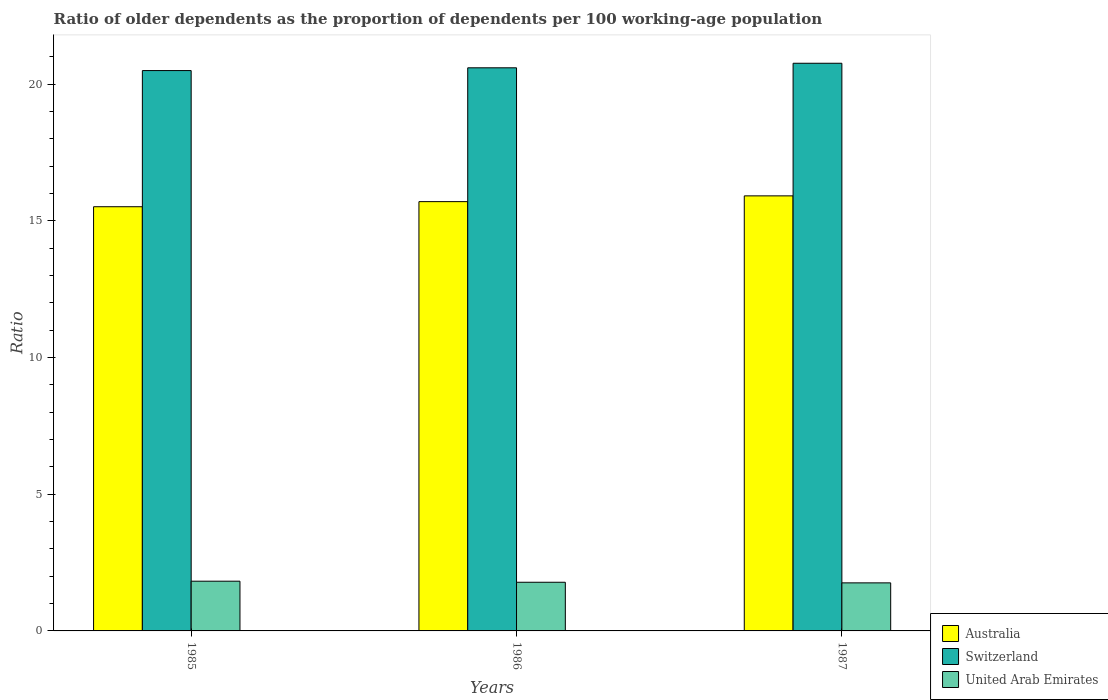How many different coloured bars are there?
Your answer should be very brief. 3. Are the number of bars on each tick of the X-axis equal?
Make the answer very short. Yes. How many bars are there on the 1st tick from the left?
Give a very brief answer. 3. What is the age dependency ratio(old) in Australia in 1985?
Your answer should be very brief. 15.51. Across all years, what is the maximum age dependency ratio(old) in Australia?
Offer a very short reply. 15.91. Across all years, what is the minimum age dependency ratio(old) in Australia?
Your response must be concise. 15.51. In which year was the age dependency ratio(old) in Australia maximum?
Your response must be concise. 1987. What is the total age dependency ratio(old) in Australia in the graph?
Your answer should be compact. 47.12. What is the difference between the age dependency ratio(old) in United Arab Emirates in 1985 and that in 1986?
Your answer should be compact. 0.04. What is the difference between the age dependency ratio(old) in Australia in 1986 and the age dependency ratio(old) in Switzerland in 1987?
Your answer should be very brief. -5.06. What is the average age dependency ratio(old) in Australia per year?
Give a very brief answer. 15.71. In the year 1987, what is the difference between the age dependency ratio(old) in Australia and age dependency ratio(old) in Switzerland?
Provide a succinct answer. -4.85. What is the ratio of the age dependency ratio(old) in Australia in 1985 to that in 1986?
Provide a succinct answer. 0.99. What is the difference between the highest and the second highest age dependency ratio(old) in Australia?
Keep it short and to the point. 0.21. What is the difference between the highest and the lowest age dependency ratio(old) in Switzerland?
Provide a succinct answer. 0.27. What does the 3rd bar from the right in 1985 represents?
Give a very brief answer. Australia. How many bars are there?
Offer a very short reply. 9. Are all the bars in the graph horizontal?
Give a very brief answer. No. How many years are there in the graph?
Make the answer very short. 3. What is the difference between two consecutive major ticks on the Y-axis?
Provide a succinct answer. 5. Are the values on the major ticks of Y-axis written in scientific E-notation?
Offer a very short reply. No. What is the title of the graph?
Your answer should be very brief. Ratio of older dependents as the proportion of dependents per 100 working-age population. What is the label or title of the X-axis?
Keep it short and to the point. Years. What is the label or title of the Y-axis?
Provide a succinct answer. Ratio. What is the Ratio in Australia in 1985?
Provide a succinct answer. 15.51. What is the Ratio in Switzerland in 1985?
Provide a succinct answer. 20.49. What is the Ratio of United Arab Emirates in 1985?
Your answer should be very brief. 1.82. What is the Ratio in Australia in 1986?
Give a very brief answer. 15.7. What is the Ratio of Switzerland in 1986?
Give a very brief answer. 20.59. What is the Ratio in United Arab Emirates in 1986?
Your answer should be very brief. 1.78. What is the Ratio of Australia in 1987?
Keep it short and to the point. 15.91. What is the Ratio of Switzerland in 1987?
Ensure brevity in your answer.  20.76. What is the Ratio of United Arab Emirates in 1987?
Ensure brevity in your answer.  1.76. Across all years, what is the maximum Ratio in Australia?
Ensure brevity in your answer.  15.91. Across all years, what is the maximum Ratio in Switzerland?
Make the answer very short. 20.76. Across all years, what is the maximum Ratio in United Arab Emirates?
Give a very brief answer. 1.82. Across all years, what is the minimum Ratio in Australia?
Give a very brief answer. 15.51. Across all years, what is the minimum Ratio in Switzerland?
Provide a succinct answer. 20.49. Across all years, what is the minimum Ratio in United Arab Emirates?
Your answer should be very brief. 1.76. What is the total Ratio in Australia in the graph?
Offer a very short reply. 47.12. What is the total Ratio of Switzerland in the graph?
Offer a terse response. 61.85. What is the total Ratio of United Arab Emirates in the graph?
Provide a short and direct response. 5.36. What is the difference between the Ratio in Australia in 1985 and that in 1986?
Provide a short and direct response. -0.19. What is the difference between the Ratio in Switzerland in 1985 and that in 1986?
Your answer should be very brief. -0.1. What is the difference between the Ratio of United Arab Emirates in 1985 and that in 1986?
Keep it short and to the point. 0.04. What is the difference between the Ratio of Australia in 1985 and that in 1987?
Offer a terse response. -0.4. What is the difference between the Ratio in Switzerland in 1985 and that in 1987?
Your response must be concise. -0.27. What is the difference between the Ratio in United Arab Emirates in 1985 and that in 1987?
Provide a short and direct response. 0.06. What is the difference between the Ratio of Australia in 1986 and that in 1987?
Offer a terse response. -0.21. What is the difference between the Ratio in Switzerland in 1986 and that in 1987?
Offer a very short reply. -0.17. What is the difference between the Ratio of United Arab Emirates in 1986 and that in 1987?
Offer a very short reply. 0.02. What is the difference between the Ratio in Australia in 1985 and the Ratio in Switzerland in 1986?
Your answer should be compact. -5.08. What is the difference between the Ratio of Australia in 1985 and the Ratio of United Arab Emirates in 1986?
Ensure brevity in your answer.  13.73. What is the difference between the Ratio of Switzerland in 1985 and the Ratio of United Arab Emirates in 1986?
Keep it short and to the point. 18.71. What is the difference between the Ratio of Australia in 1985 and the Ratio of Switzerland in 1987?
Ensure brevity in your answer.  -5.25. What is the difference between the Ratio in Australia in 1985 and the Ratio in United Arab Emirates in 1987?
Your answer should be compact. 13.76. What is the difference between the Ratio in Switzerland in 1985 and the Ratio in United Arab Emirates in 1987?
Your answer should be very brief. 18.73. What is the difference between the Ratio in Australia in 1986 and the Ratio in Switzerland in 1987?
Make the answer very short. -5.06. What is the difference between the Ratio of Australia in 1986 and the Ratio of United Arab Emirates in 1987?
Offer a terse response. 13.94. What is the difference between the Ratio in Switzerland in 1986 and the Ratio in United Arab Emirates in 1987?
Provide a succinct answer. 18.84. What is the average Ratio of Australia per year?
Your response must be concise. 15.71. What is the average Ratio in Switzerland per year?
Offer a terse response. 20.62. What is the average Ratio in United Arab Emirates per year?
Your answer should be compact. 1.79. In the year 1985, what is the difference between the Ratio in Australia and Ratio in Switzerland?
Provide a short and direct response. -4.98. In the year 1985, what is the difference between the Ratio of Australia and Ratio of United Arab Emirates?
Provide a succinct answer. 13.69. In the year 1985, what is the difference between the Ratio of Switzerland and Ratio of United Arab Emirates?
Your response must be concise. 18.67. In the year 1986, what is the difference between the Ratio of Australia and Ratio of Switzerland?
Provide a succinct answer. -4.89. In the year 1986, what is the difference between the Ratio in Australia and Ratio in United Arab Emirates?
Make the answer very short. 13.92. In the year 1986, what is the difference between the Ratio of Switzerland and Ratio of United Arab Emirates?
Offer a very short reply. 18.81. In the year 1987, what is the difference between the Ratio of Australia and Ratio of Switzerland?
Offer a very short reply. -4.85. In the year 1987, what is the difference between the Ratio in Australia and Ratio in United Arab Emirates?
Give a very brief answer. 14.15. In the year 1987, what is the difference between the Ratio of Switzerland and Ratio of United Arab Emirates?
Offer a very short reply. 19. What is the ratio of the Ratio of Australia in 1985 to that in 1986?
Your response must be concise. 0.99. What is the ratio of the Ratio in Switzerland in 1985 to that in 1986?
Provide a short and direct response. 1. What is the ratio of the Ratio of United Arab Emirates in 1985 to that in 1986?
Your response must be concise. 1.02. What is the ratio of the Ratio in Switzerland in 1985 to that in 1987?
Your answer should be very brief. 0.99. What is the ratio of the Ratio in United Arab Emirates in 1985 to that in 1987?
Your answer should be very brief. 1.03. What is the ratio of the Ratio in Australia in 1986 to that in 1987?
Your response must be concise. 0.99. What is the ratio of the Ratio in United Arab Emirates in 1986 to that in 1987?
Your answer should be compact. 1.01. What is the difference between the highest and the second highest Ratio of Australia?
Offer a terse response. 0.21. What is the difference between the highest and the second highest Ratio in Switzerland?
Provide a short and direct response. 0.17. What is the difference between the highest and the second highest Ratio of United Arab Emirates?
Ensure brevity in your answer.  0.04. What is the difference between the highest and the lowest Ratio in Australia?
Keep it short and to the point. 0.4. What is the difference between the highest and the lowest Ratio in Switzerland?
Your answer should be very brief. 0.27. What is the difference between the highest and the lowest Ratio in United Arab Emirates?
Your response must be concise. 0.06. 